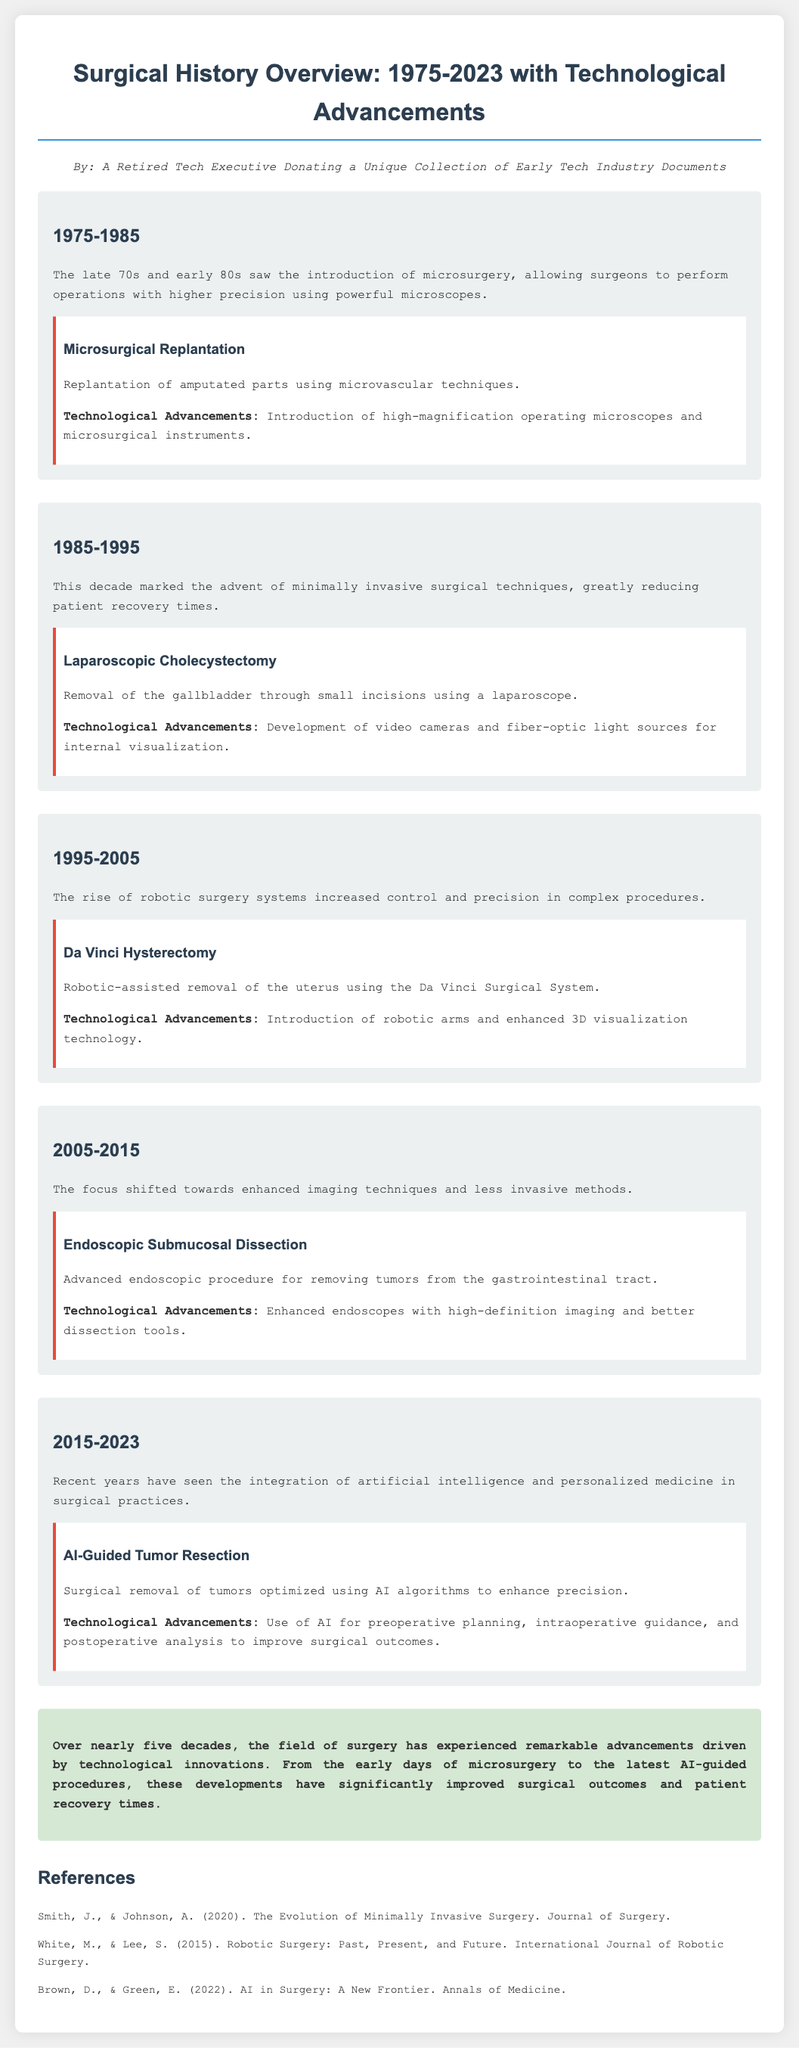what surgical technique was introduced in the 1970s? The 1970s saw the introduction of microsurgery, a technique allowing for higher precision in operations.
Answer: microsurgery what procedure is associated with laparoscopic techniques? Laparoscopic techniques are primarily exemplified through the removal of the gallbladder.
Answer: Laparoscopic Cholecystectomy which surgical system was used for robotic-assisted procedures? The Da Vinci Surgical System was the robotic system used for various surgical procedures.
Answer: Da Vinci Surgical System what was a key technological advancement in 1995-2005? A significant technological advancement during 1995-2005 was the introduction of robotic arms and enhanced 3D visualization technology.
Answer: robotic arms and enhanced 3D visualization technology how has AI impacted surgical procedures recently? AI has optimized surgical procedures by enhancing precision through preoperative planning, intraoperative guidance, and postoperative analysis.
Answer: AI algorithms what does endoscopic submucosal dissection focus on? Endoscopic submucosal dissection primarily focuses on removing tumors from the gastrointestinal tract.
Answer: removing tumors what is the primary focus of surgical advancements from 2005 to 2015? The primary focus during this period was on enhanced imaging techniques and less invasive methods.
Answer: enhanced imaging techniques and less invasive methods how many years span the surgical history overview documented? The document covers a period of 48 years from 1975 to 2023.
Answer: 48 years who are the authors of the references listed? The references are authored by Smith & Johnson, White & Lee, and Brown & Green.
Answer: Smith & Johnson; White & Lee; Brown & Green 